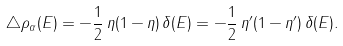Convert formula to latex. <formula><loc_0><loc_0><loc_500><loc_500>\triangle \rho _ { \alpha } ( E ) = - \frac { 1 } { 2 } \, \eta ( 1 - \eta ) \, \delta ( E ) = - \frac { 1 } { 2 } \, \eta ^ { \prime } ( 1 - \eta ^ { \prime } ) \, \delta ( E ) .</formula> 